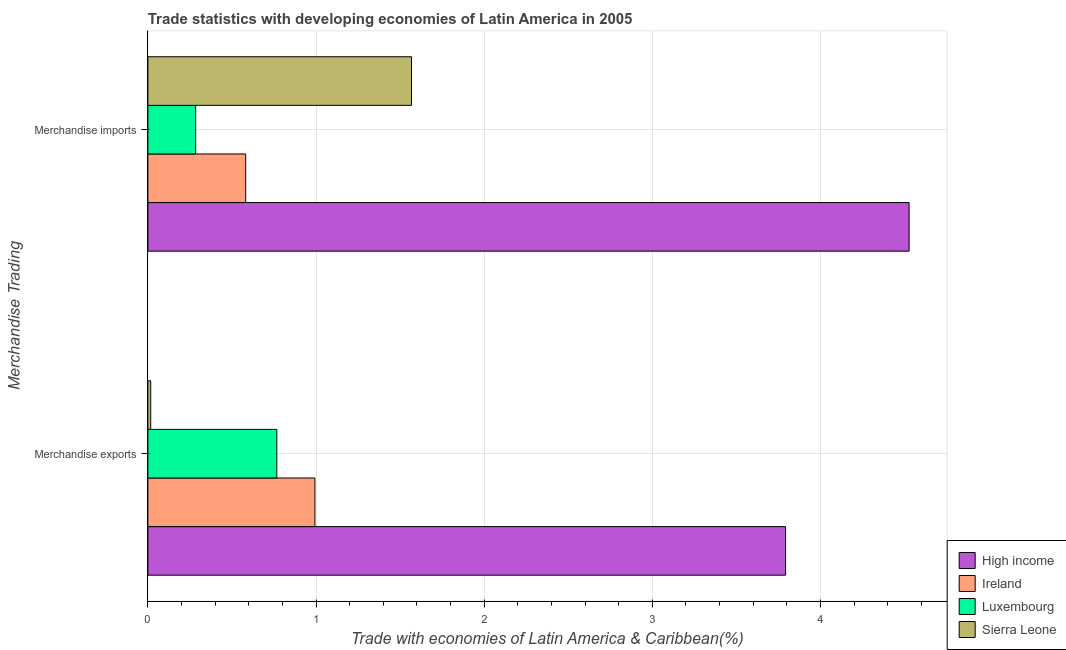How many different coloured bars are there?
Give a very brief answer. 4. How many bars are there on the 2nd tick from the top?
Provide a short and direct response. 4. How many bars are there on the 1st tick from the bottom?
Your answer should be compact. 4. What is the label of the 1st group of bars from the top?
Your response must be concise. Merchandise imports. What is the merchandise imports in Luxembourg?
Keep it short and to the point. 0.28. Across all countries, what is the maximum merchandise exports?
Your answer should be compact. 3.79. Across all countries, what is the minimum merchandise imports?
Your answer should be compact. 0.28. In which country was the merchandise imports maximum?
Provide a succinct answer. High income. In which country was the merchandise imports minimum?
Provide a short and direct response. Luxembourg. What is the total merchandise imports in the graph?
Provide a short and direct response. 6.96. What is the difference between the merchandise imports in High income and that in Luxembourg?
Provide a short and direct response. 4.24. What is the difference between the merchandise exports in Luxembourg and the merchandise imports in High income?
Give a very brief answer. -3.76. What is the average merchandise exports per country?
Keep it short and to the point. 1.39. What is the difference between the merchandise imports and merchandise exports in Luxembourg?
Ensure brevity in your answer.  -0.48. What is the ratio of the merchandise exports in Ireland to that in Luxembourg?
Provide a short and direct response. 1.3. Is the merchandise exports in Ireland less than that in Sierra Leone?
Make the answer very short. No. In how many countries, is the merchandise imports greater than the average merchandise imports taken over all countries?
Offer a terse response. 1. What does the 3rd bar from the bottom in Merchandise imports represents?
Give a very brief answer. Luxembourg. Are all the bars in the graph horizontal?
Keep it short and to the point. Yes. Are the values on the major ticks of X-axis written in scientific E-notation?
Provide a short and direct response. No. Does the graph contain any zero values?
Give a very brief answer. No. How are the legend labels stacked?
Your answer should be compact. Vertical. What is the title of the graph?
Provide a short and direct response. Trade statistics with developing economies of Latin America in 2005. Does "Korea (Republic)" appear as one of the legend labels in the graph?
Your response must be concise. No. What is the label or title of the X-axis?
Offer a terse response. Trade with economies of Latin America & Caribbean(%). What is the label or title of the Y-axis?
Offer a terse response. Merchandise Trading. What is the Trade with economies of Latin America & Caribbean(%) in High income in Merchandise exports?
Ensure brevity in your answer.  3.79. What is the Trade with economies of Latin America & Caribbean(%) in Ireland in Merchandise exports?
Offer a terse response. 0.99. What is the Trade with economies of Latin America & Caribbean(%) of Luxembourg in Merchandise exports?
Offer a very short reply. 0.77. What is the Trade with economies of Latin America & Caribbean(%) of Sierra Leone in Merchandise exports?
Give a very brief answer. 0.02. What is the Trade with economies of Latin America & Caribbean(%) in High income in Merchandise imports?
Keep it short and to the point. 4.53. What is the Trade with economies of Latin America & Caribbean(%) in Ireland in Merchandise imports?
Offer a terse response. 0.58. What is the Trade with economies of Latin America & Caribbean(%) of Luxembourg in Merchandise imports?
Ensure brevity in your answer.  0.28. What is the Trade with economies of Latin America & Caribbean(%) in Sierra Leone in Merchandise imports?
Give a very brief answer. 1.57. Across all Merchandise Trading, what is the maximum Trade with economies of Latin America & Caribbean(%) in High income?
Your answer should be very brief. 4.53. Across all Merchandise Trading, what is the maximum Trade with economies of Latin America & Caribbean(%) of Ireland?
Offer a very short reply. 0.99. Across all Merchandise Trading, what is the maximum Trade with economies of Latin America & Caribbean(%) of Luxembourg?
Offer a very short reply. 0.77. Across all Merchandise Trading, what is the maximum Trade with economies of Latin America & Caribbean(%) of Sierra Leone?
Provide a succinct answer. 1.57. Across all Merchandise Trading, what is the minimum Trade with economies of Latin America & Caribbean(%) of High income?
Provide a short and direct response. 3.79. Across all Merchandise Trading, what is the minimum Trade with economies of Latin America & Caribbean(%) of Ireland?
Provide a short and direct response. 0.58. Across all Merchandise Trading, what is the minimum Trade with economies of Latin America & Caribbean(%) in Luxembourg?
Provide a succinct answer. 0.28. Across all Merchandise Trading, what is the minimum Trade with economies of Latin America & Caribbean(%) of Sierra Leone?
Give a very brief answer. 0.02. What is the total Trade with economies of Latin America & Caribbean(%) in High income in the graph?
Make the answer very short. 8.32. What is the total Trade with economies of Latin America & Caribbean(%) in Ireland in the graph?
Make the answer very short. 1.58. What is the total Trade with economies of Latin America & Caribbean(%) in Luxembourg in the graph?
Your response must be concise. 1.05. What is the total Trade with economies of Latin America & Caribbean(%) of Sierra Leone in the graph?
Ensure brevity in your answer.  1.58. What is the difference between the Trade with economies of Latin America & Caribbean(%) in High income in Merchandise exports and that in Merchandise imports?
Ensure brevity in your answer.  -0.73. What is the difference between the Trade with economies of Latin America & Caribbean(%) in Ireland in Merchandise exports and that in Merchandise imports?
Your response must be concise. 0.41. What is the difference between the Trade with economies of Latin America & Caribbean(%) in Luxembourg in Merchandise exports and that in Merchandise imports?
Your response must be concise. 0.48. What is the difference between the Trade with economies of Latin America & Caribbean(%) of Sierra Leone in Merchandise exports and that in Merchandise imports?
Keep it short and to the point. -1.55. What is the difference between the Trade with economies of Latin America & Caribbean(%) in High income in Merchandise exports and the Trade with economies of Latin America & Caribbean(%) in Ireland in Merchandise imports?
Ensure brevity in your answer.  3.21. What is the difference between the Trade with economies of Latin America & Caribbean(%) in High income in Merchandise exports and the Trade with economies of Latin America & Caribbean(%) in Luxembourg in Merchandise imports?
Your response must be concise. 3.51. What is the difference between the Trade with economies of Latin America & Caribbean(%) in High income in Merchandise exports and the Trade with economies of Latin America & Caribbean(%) in Sierra Leone in Merchandise imports?
Keep it short and to the point. 2.22. What is the difference between the Trade with economies of Latin America & Caribbean(%) in Ireland in Merchandise exports and the Trade with economies of Latin America & Caribbean(%) in Luxembourg in Merchandise imports?
Your answer should be compact. 0.71. What is the difference between the Trade with economies of Latin America & Caribbean(%) in Ireland in Merchandise exports and the Trade with economies of Latin America & Caribbean(%) in Sierra Leone in Merchandise imports?
Your response must be concise. -0.57. What is the difference between the Trade with economies of Latin America & Caribbean(%) of Luxembourg in Merchandise exports and the Trade with economies of Latin America & Caribbean(%) of Sierra Leone in Merchandise imports?
Provide a short and direct response. -0.8. What is the average Trade with economies of Latin America & Caribbean(%) of High income per Merchandise Trading?
Ensure brevity in your answer.  4.16. What is the average Trade with economies of Latin America & Caribbean(%) of Ireland per Merchandise Trading?
Make the answer very short. 0.79. What is the average Trade with economies of Latin America & Caribbean(%) in Luxembourg per Merchandise Trading?
Offer a terse response. 0.53. What is the average Trade with economies of Latin America & Caribbean(%) of Sierra Leone per Merchandise Trading?
Provide a short and direct response. 0.79. What is the difference between the Trade with economies of Latin America & Caribbean(%) of High income and Trade with economies of Latin America & Caribbean(%) of Ireland in Merchandise exports?
Provide a short and direct response. 2.8. What is the difference between the Trade with economies of Latin America & Caribbean(%) of High income and Trade with economies of Latin America & Caribbean(%) of Luxembourg in Merchandise exports?
Your answer should be compact. 3.03. What is the difference between the Trade with economies of Latin America & Caribbean(%) of High income and Trade with economies of Latin America & Caribbean(%) of Sierra Leone in Merchandise exports?
Provide a succinct answer. 3.78. What is the difference between the Trade with economies of Latin America & Caribbean(%) in Ireland and Trade with economies of Latin America & Caribbean(%) in Luxembourg in Merchandise exports?
Your response must be concise. 0.23. What is the difference between the Trade with economies of Latin America & Caribbean(%) of Ireland and Trade with economies of Latin America & Caribbean(%) of Sierra Leone in Merchandise exports?
Keep it short and to the point. 0.98. What is the difference between the Trade with economies of Latin America & Caribbean(%) of Luxembourg and Trade with economies of Latin America & Caribbean(%) of Sierra Leone in Merchandise exports?
Offer a very short reply. 0.75. What is the difference between the Trade with economies of Latin America & Caribbean(%) in High income and Trade with economies of Latin America & Caribbean(%) in Ireland in Merchandise imports?
Give a very brief answer. 3.95. What is the difference between the Trade with economies of Latin America & Caribbean(%) in High income and Trade with economies of Latin America & Caribbean(%) in Luxembourg in Merchandise imports?
Your response must be concise. 4.24. What is the difference between the Trade with economies of Latin America & Caribbean(%) of High income and Trade with economies of Latin America & Caribbean(%) of Sierra Leone in Merchandise imports?
Offer a terse response. 2.96. What is the difference between the Trade with economies of Latin America & Caribbean(%) of Ireland and Trade with economies of Latin America & Caribbean(%) of Luxembourg in Merchandise imports?
Make the answer very short. 0.3. What is the difference between the Trade with economies of Latin America & Caribbean(%) in Ireland and Trade with economies of Latin America & Caribbean(%) in Sierra Leone in Merchandise imports?
Give a very brief answer. -0.99. What is the difference between the Trade with economies of Latin America & Caribbean(%) in Luxembourg and Trade with economies of Latin America & Caribbean(%) in Sierra Leone in Merchandise imports?
Make the answer very short. -1.28. What is the ratio of the Trade with economies of Latin America & Caribbean(%) of High income in Merchandise exports to that in Merchandise imports?
Give a very brief answer. 0.84. What is the ratio of the Trade with economies of Latin America & Caribbean(%) of Ireland in Merchandise exports to that in Merchandise imports?
Give a very brief answer. 1.71. What is the ratio of the Trade with economies of Latin America & Caribbean(%) of Luxembourg in Merchandise exports to that in Merchandise imports?
Your response must be concise. 2.7. What is the ratio of the Trade with economies of Latin America & Caribbean(%) in Sierra Leone in Merchandise exports to that in Merchandise imports?
Ensure brevity in your answer.  0.01. What is the difference between the highest and the second highest Trade with economies of Latin America & Caribbean(%) in High income?
Make the answer very short. 0.73. What is the difference between the highest and the second highest Trade with economies of Latin America & Caribbean(%) of Ireland?
Offer a very short reply. 0.41. What is the difference between the highest and the second highest Trade with economies of Latin America & Caribbean(%) in Luxembourg?
Offer a terse response. 0.48. What is the difference between the highest and the second highest Trade with economies of Latin America & Caribbean(%) of Sierra Leone?
Provide a short and direct response. 1.55. What is the difference between the highest and the lowest Trade with economies of Latin America & Caribbean(%) of High income?
Offer a terse response. 0.73. What is the difference between the highest and the lowest Trade with economies of Latin America & Caribbean(%) in Ireland?
Offer a very short reply. 0.41. What is the difference between the highest and the lowest Trade with economies of Latin America & Caribbean(%) in Luxembourg?
Ensure brevity in your answer.  0.48. What is the difference between the highest and the lowest Trade with economies of Latin America & Caribbean(%) in Sierra Leone?
Your answer should be very brief. 1.55. 